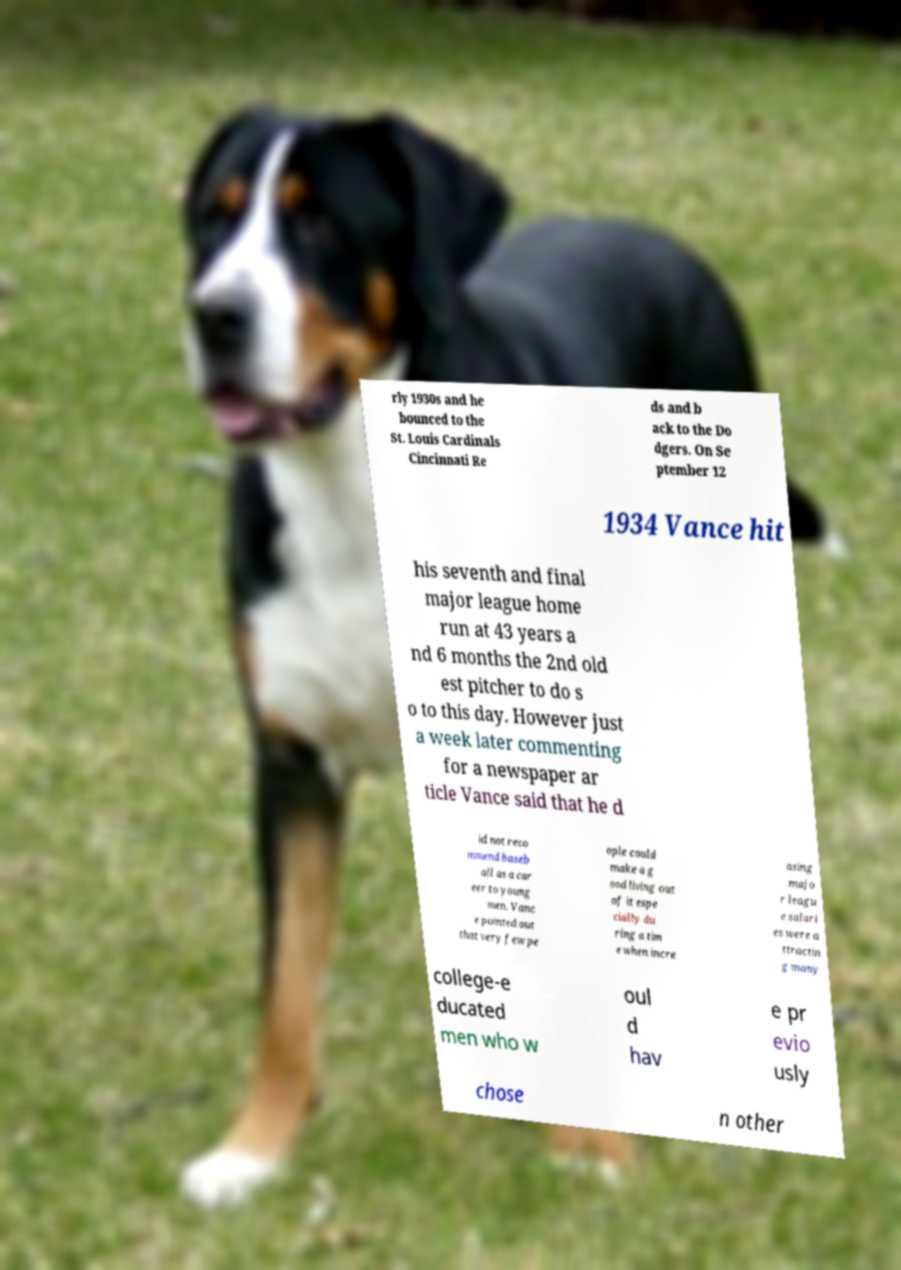Could you extract and type out the text from this image? rly 1930s and he bounced to the St. Louis Cardinals Cincinnati Re ds and b ack to the Do dgers. On Se ptember 12 1934 Vance hit his seventh and final major league home run at 43 years a nd 6 months the 2nd old est pitcher to do s o to this day. However just a week later commenting for a newspaper ar ticle Vance said that he d id not reco mmend baseb all as a car eer to young men. Vanc e pointed out that very few pe ople could make a g ood living out of it espe cially du ring a tim e when incre asing majo r leagu e salari es were a ttractin g many college-e ducated men who w oul d hav e pr evio usly chose n other 